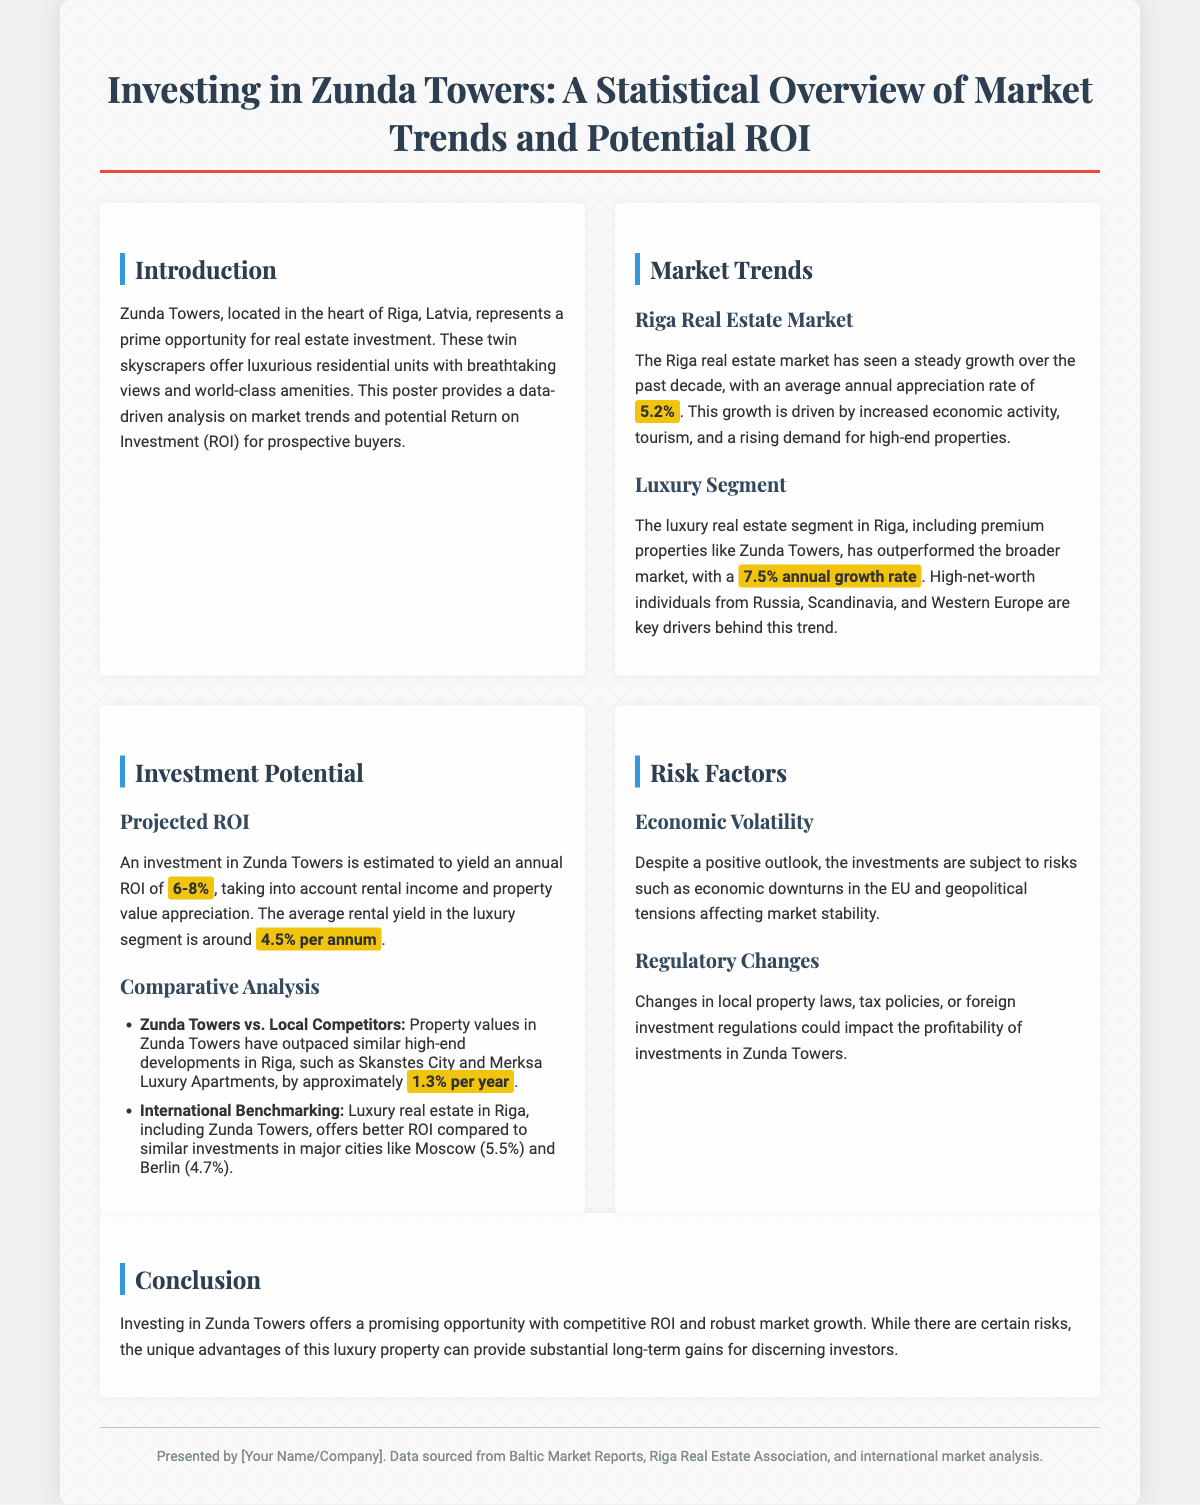What is the annual appreciation rate for the Riga real estate market? The annual appreciation rate is stated in the document as 5.2%.
Answer: 5.2% What is the annual growth rate of the luxury segment in Riga? The document specifies that the luxury real estate segment has a growth rate of 7.5%.
Answer: 7.5% What is the projected annual ROI for an investment in Zunda Towers? The projected annual ROI is described as ranging from 6-8%.
Answer: 6-8% What is the average rental yield in the luxury segment? The average rental yield mentioned in the document is 4.5% per annum.
Answer: 4.5% By how much have property values in Zunda Towers outpaced local competitors? The document states that property values have outpaced local competitors by approximately 1.3% per year.
Answer: 1.3% Which cities are used for international benchmarking in the document? The cities referenced for international benchmarking include Moscow and Berlin.
Answer: Moscow, Berlin What is the main risk factor mentioned regarding economic conditions? The main risk factor related to economic conditions is economic downturns in the EU.
Answer: Economic downturns What type of laws could impact the profitability of investments? Changes in local property laws could impact profitability as mentioned in the document.
Answer: Local property laws What is highlighted as a unique advantage of Zunda Towers for investors? The unique advantage mentioned is the competitive ROI and robust market growth of Zunda Towers.
Answer: Competitive ROI, robust market growth 